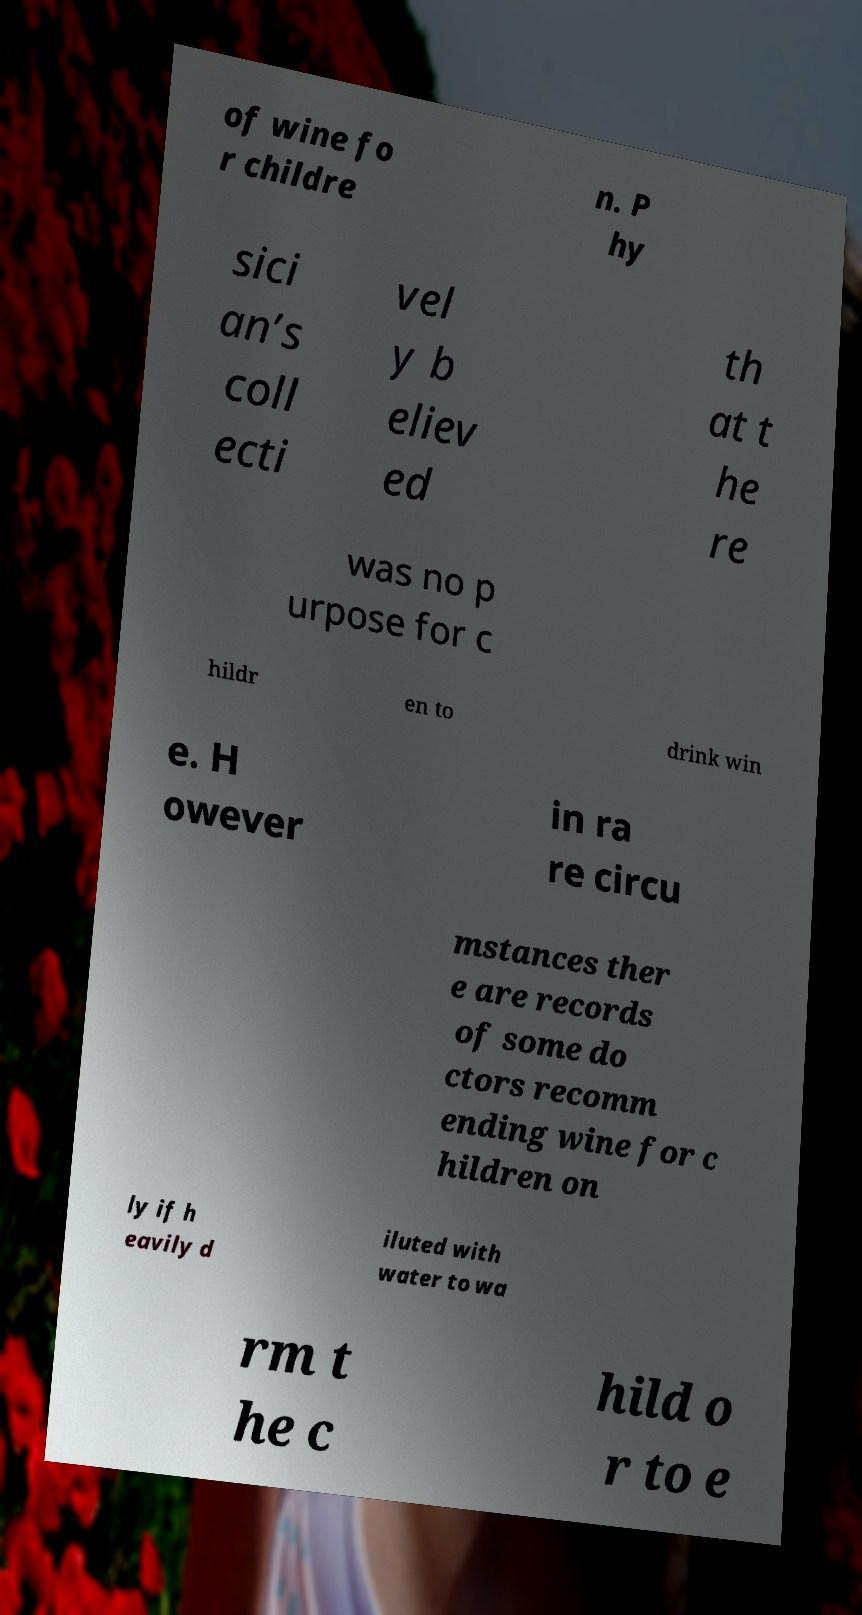For documentation purposes, I need the text within this image transcribed. Could you provide that? of wine fo r childre n. P hy sici an’s coll ecti vel y b eliev ed th at t he re was no p urpose for c hildr en to drink win e. H owever in ra re circu mstances ther e are records of some do ctors recomm ending wine for c hildren on ly if h eavily d iluted with water to wa rm t he c hild o r to e 